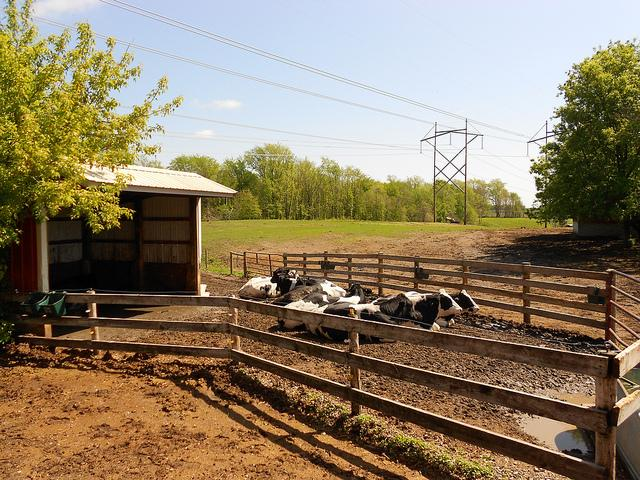What is the large structure in the background?

Choices:
A) power lines
B) business
C) skyscraper
D) stadium power lines 